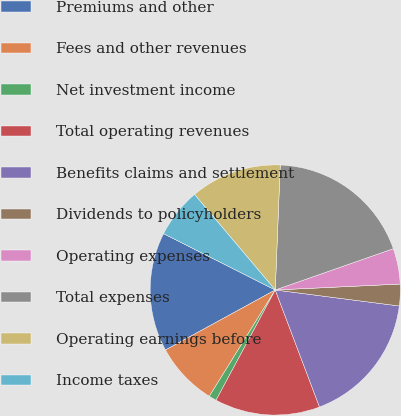<chart> <loc_0><loc_0><loc_500><loc_500><pie_chart><fcel>Premiums and other<fcel>Fees and other revenues<fcel>Net investment income<fcel>Total operating revenues<fcel>Benefits claims and settlement<fcel>Dividends to policyholders<fcel>Operating expenses<fcel>Total expenses<fcel>Operating earnings before<fcel>Income taxes<nl><fcel>15.4%<fcel>8.2%<fcel>0.99%<fcel>13.6%<fcel>17.2%<fcel>2.8%<fcel>4.6%<fcel>19.01%<fcel>11.8%<fcel>6.4%<nl></chart> 